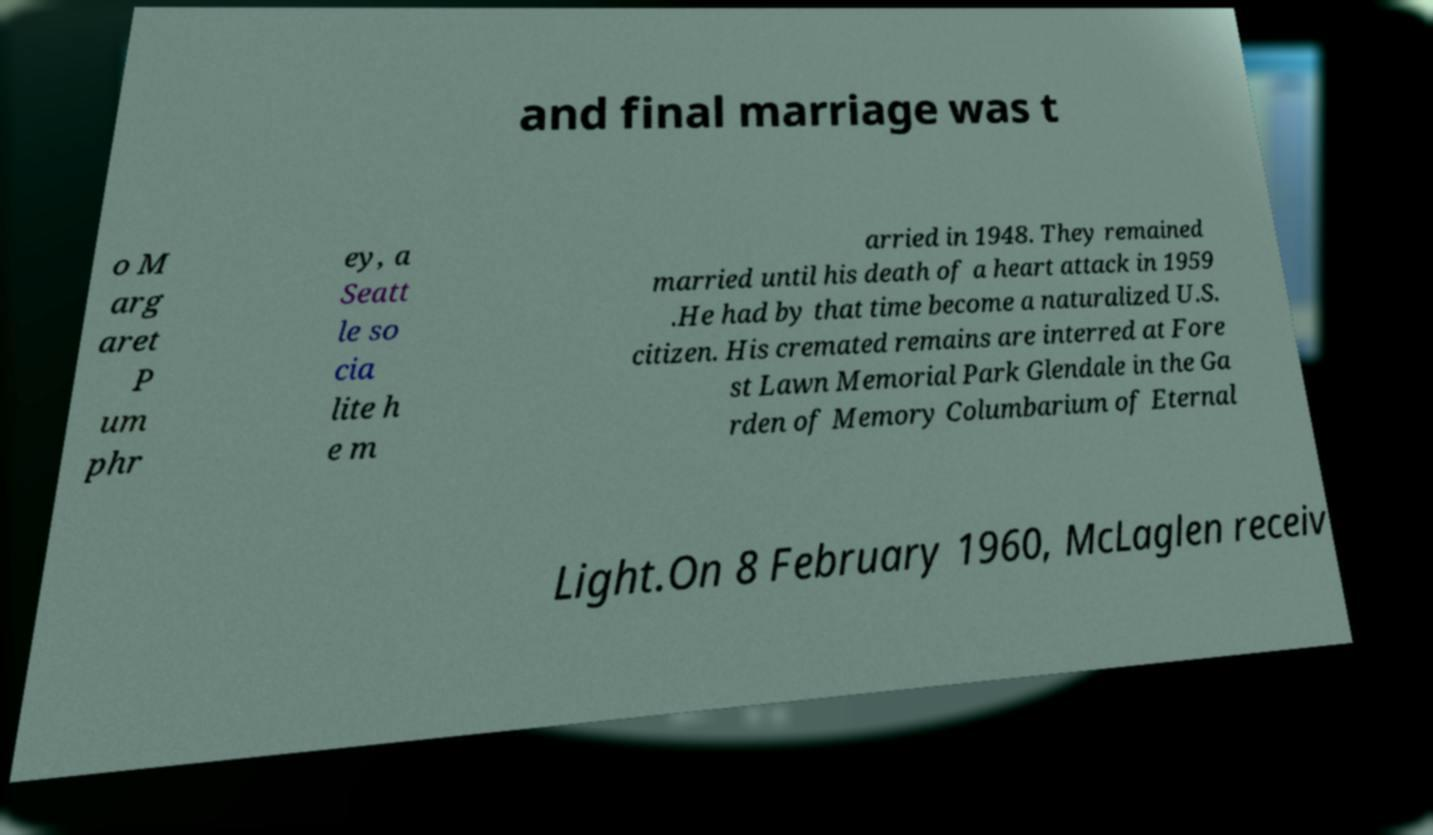Please read and relay the text visible in this image. What does it say? and final marriage was t o M arg aret P um phr ey, a Seatt le so cia lite h e m arried in 1948. They remained married until his death of a heart attack in 1959 .He had by that time become a naturalized U.S. citizen. His cremated remains are interred at Fore st Lawn Memorial Park Glendale in the Ga rden of Memory Columbarium of Eternal Light.On 8 February 1960, McLaglen receiv 